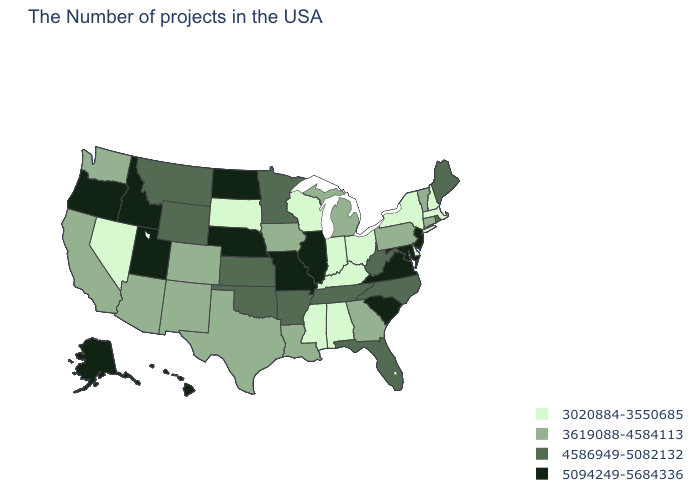Among the states that border West Virginia , which have the lowest value?
Keep it brief. Ohio, Kentucky. Does North Carolina have a higher value than Maine?
Write a very short answer. No. What is the value of New Jersey?
Answer briefly. 5094249-5684336. Name the states that have a value in the range 3619088-4584113?
Concise answer only. Vermont, Connecticut, Pennsylvania, Georgia, Michigan, Louisiana, Iowa, Texas, Colorado, New Mexico, Arizona, California, Washington. What is the lowest value in the Northeast?
Short answer required. 3020884-3550685. Among the states that border Pennsylvania , does Delaware have the highest value?
Keep it brief. No. Which states have the lowest value in the USA?
Short answer required. Massachusetts, New Hampshire, New York, Delaware, Ohio, Kentucky, Indiana, Alabama, Wisconsin, Mississippi, South Dakota, Nevada. What is the lowest value in the USA?
Be succinct. 3020884-3550685. Does the map have missing data?
Answer briefly. No. Which states have the lowest value in the Northeast?
Short answer required. Massachusetts, New Hampshire, New York. What is the value of Texas?
Short answer required. 3619088-4584113. Does Alabama have a higher value than Idaho?
Concise answer only. No. What is the value of Colorado?
Short answer required. 3619088-4584113. Does Delaware have a lower value than Connecticut?
Answer briefly. Yes. Name the states that have a value in the range 5094249-5684336?
Answer briefly. New Jersey, Maryland, Virginia, South Carolina, Illinois, Missouri, Nebraska, North Dakota, Utah, Idaho, Oregon, Alaska, Hawaii. 